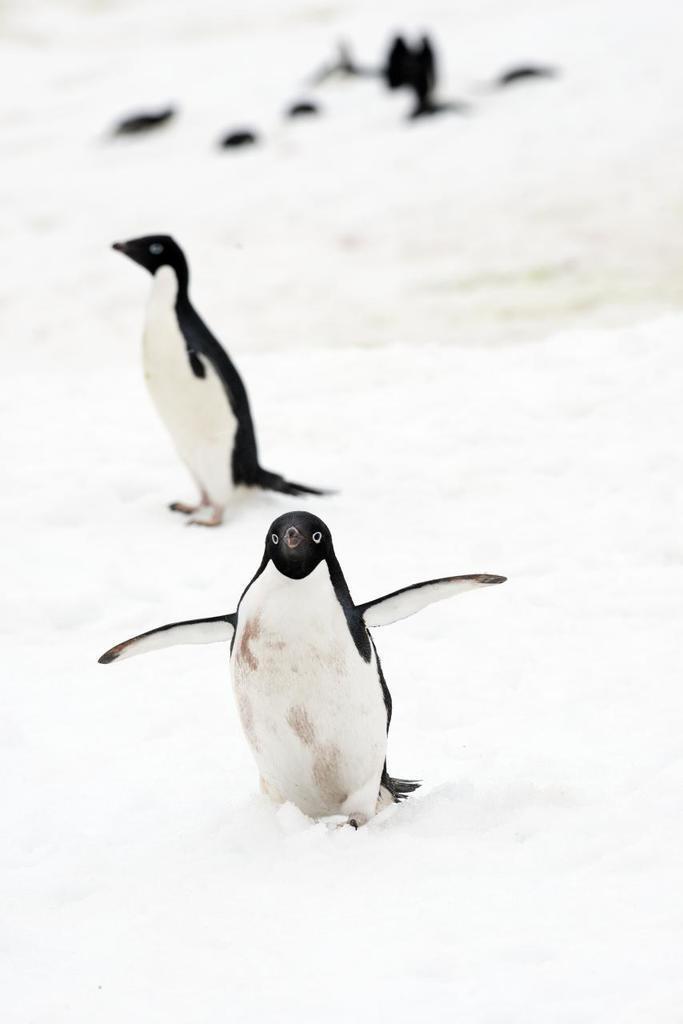Can you describe this image briefly? In this image we can see some penguins on the snow. 